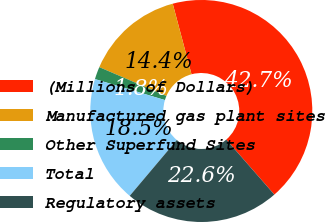Convert chart. <chart><loc_0><loc_0><loc_500><loc_500><pie_chart><fcel>(Millions of Dollars)<fcel>Manufactured gas plant sites<fcel>Other Superfund Sites<fcel>Total<fcel>Regulatory assets<nl><fcel>42.72%<fcel>14.4%<fcel>1.82%<fcel>18.49%<fcel>22.58%<nl></chart> 